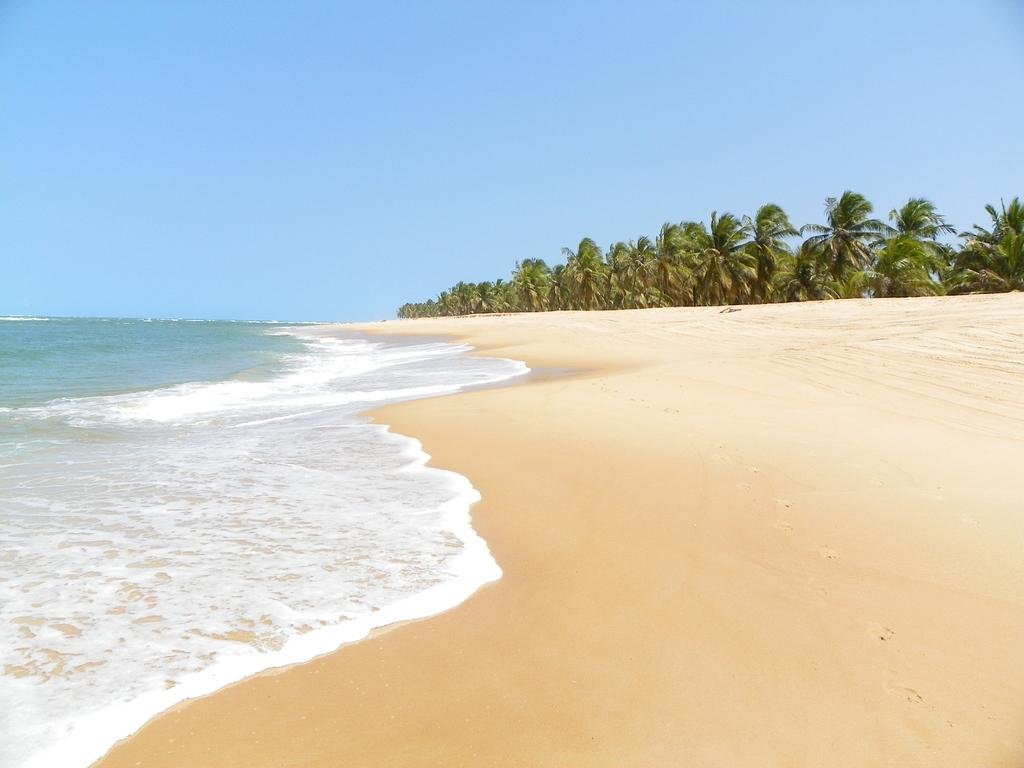What type of natural environment is depicted in the image? The image contains water, sand, and trees, which suggests a beach or coastal setting. Can you describe the sky in the image? The sky is clear and visible in the background of the image. What type of vegetation can be seen in the image? There are trees in the background of the image. What type of meat can be seen hanging from the trees in the image? There is no meat hanging from the trees in the image; it features a natural environment with water, sand, trees, and a clear sky. 